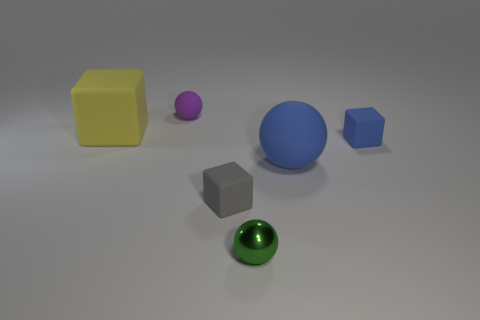Add 2 small gray cylinders. How many objects exist? 8 Subtract all big blocks. How many blocks are left? 2 Subtract 1 balls. How many balls are left? 2 Subtract all yellow balls. How many yellow cubes are left? 1 Subtract 0 cyan cylinders. How many objects are left? 6 Subtract all green balls. Subtract all cyan cubes. How many balls are left? 2 Subtract all purple rubber objects. Subtract all purple objects. How many objects are left? 4 Add 5 big yellow rubber cubes. How many big yellow rubber cubes are left? 6 Add 1 tiny things. How many tiny things exist? 5 